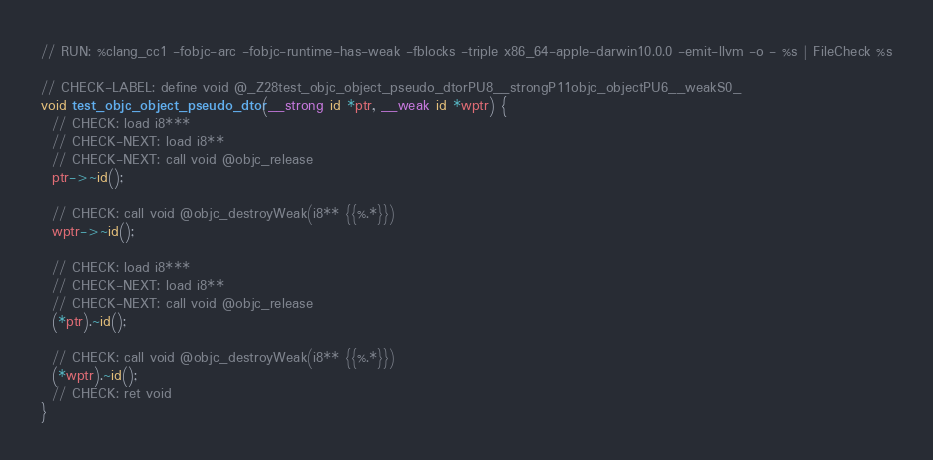Convert code to text. <code><loc_0><loc_0><loc_500><loc_500><_ObjectiveC_>// RUN: %clang_cc1 -fobjc-arc -fobjc-runtime-has-weak -fblocks -triple x86_64-apple-darwin10.0.0 -emit-llvm -o - %s | FileCheck %s

// CHECK-LABEL: define void @_Z28test_objc_object_pseudo_dtorPU8__strongP11objc_objectPU6__weakS0_
void test_objc_object_pseudo_dtor(__strong id *ptr, __weak id *wptr) {
  // CHECK: load i8***
  // CHECK-NEXT: load i8** 
  // CHECK-NEXT: call void @objc_release
  ptr->~id();

  // CHECK: call void @objc_destroyWeak(i8** {{%.*}})
  wptr->~id();

  // CHECK: load i8***
  // CHECK-NEXT: load i8** 
  // CHECK-NEXT: call void @objc_release
  (*ptr).~id();

  // CHECK: call void @objc_destroyWeak(i8** {{%.*}})
  (*wptr).~id();
  // CHECK: ret void
}
</code> 